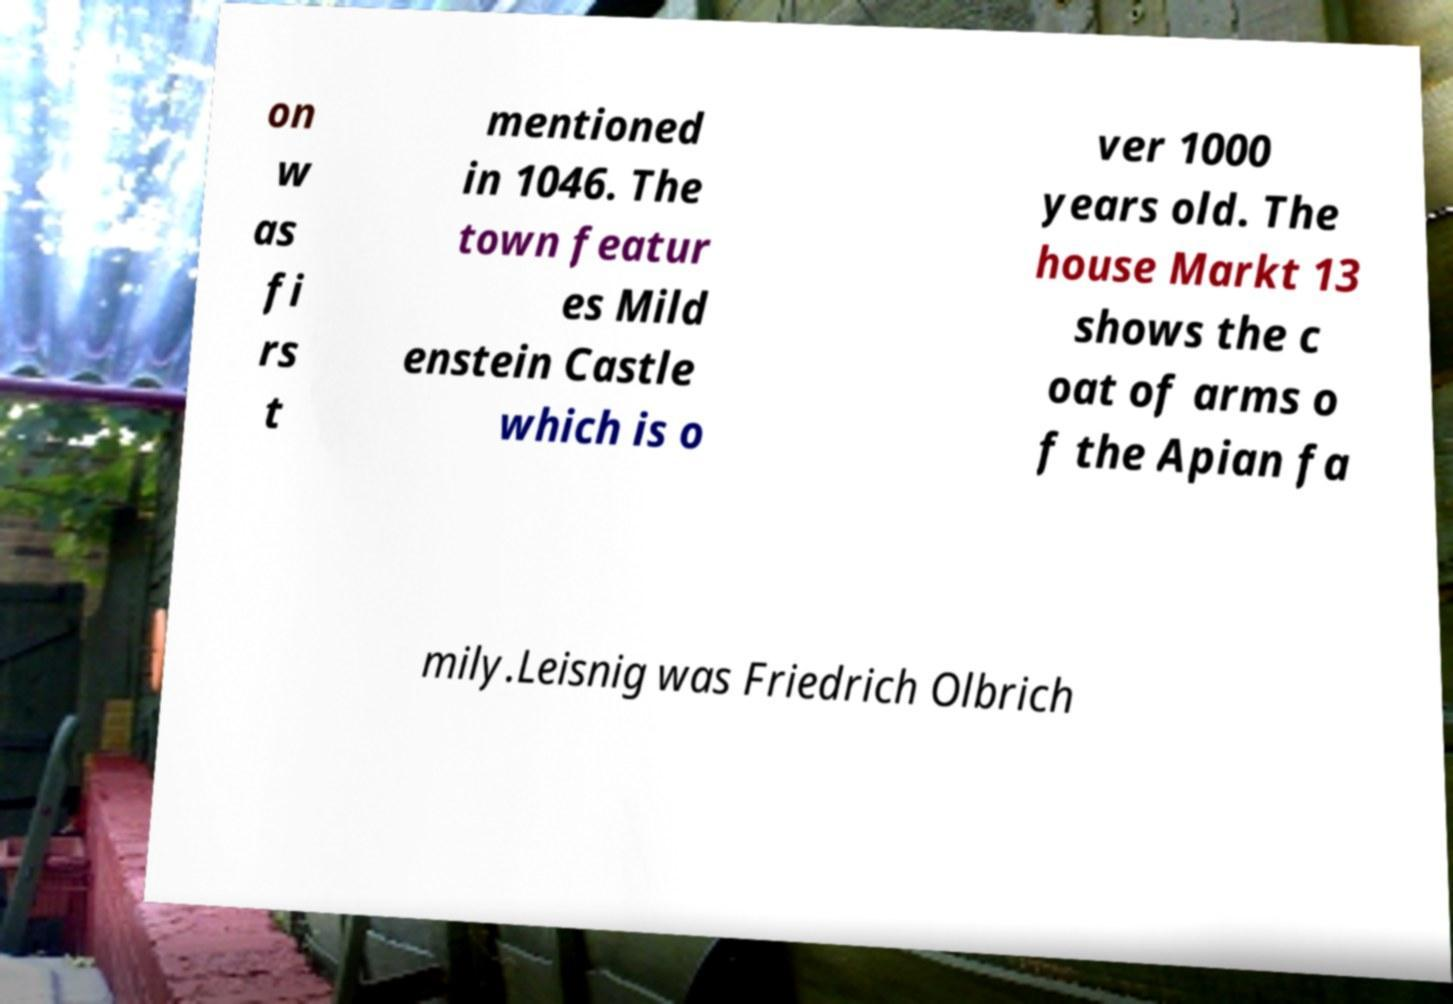Can you accurately transcribe the text from the provided image for me? on w as fi rs t mentioned in 1046. The town featur es Mild enstein Castle which is o ver 1000 years old. The house Markt 13 shows the c oat of arms o f the Apian fa mily.Leisnig was Friedrich Olbrich 